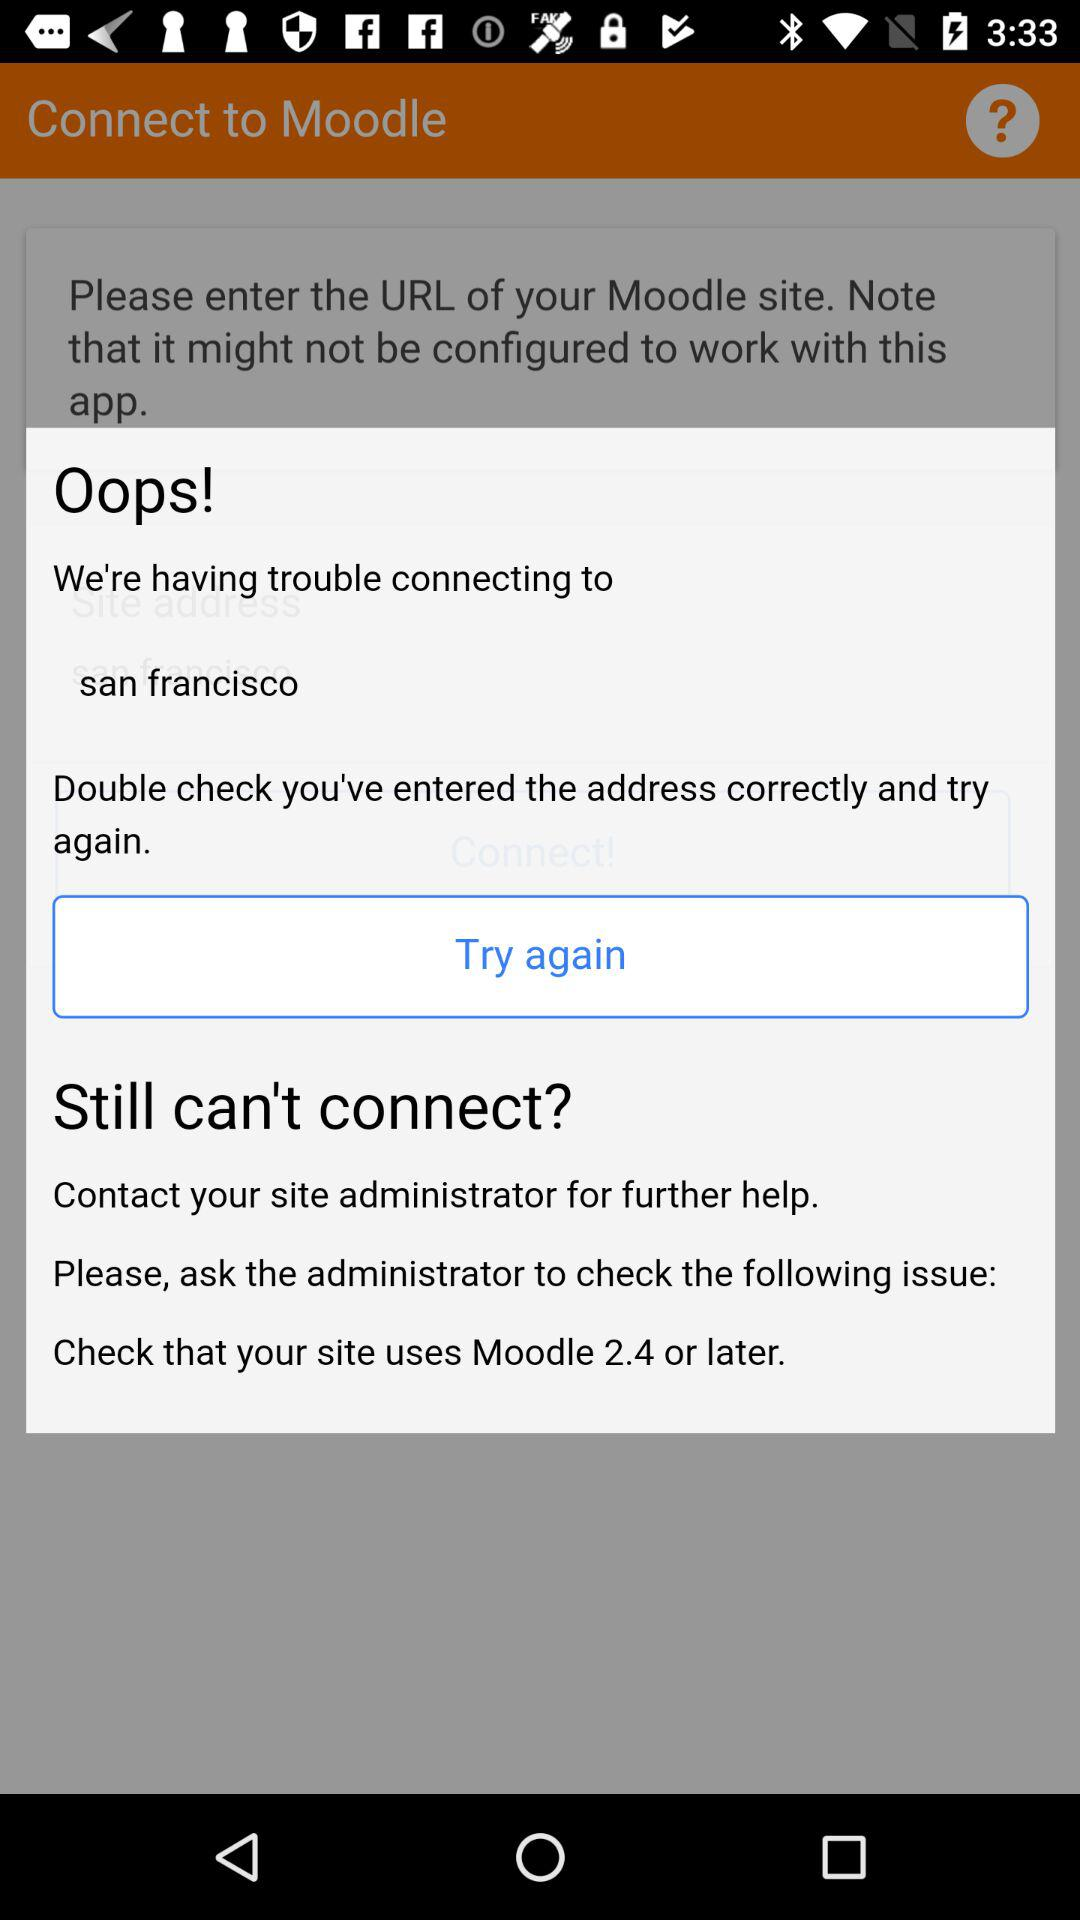What's the city name? The city name is San Francisco. 